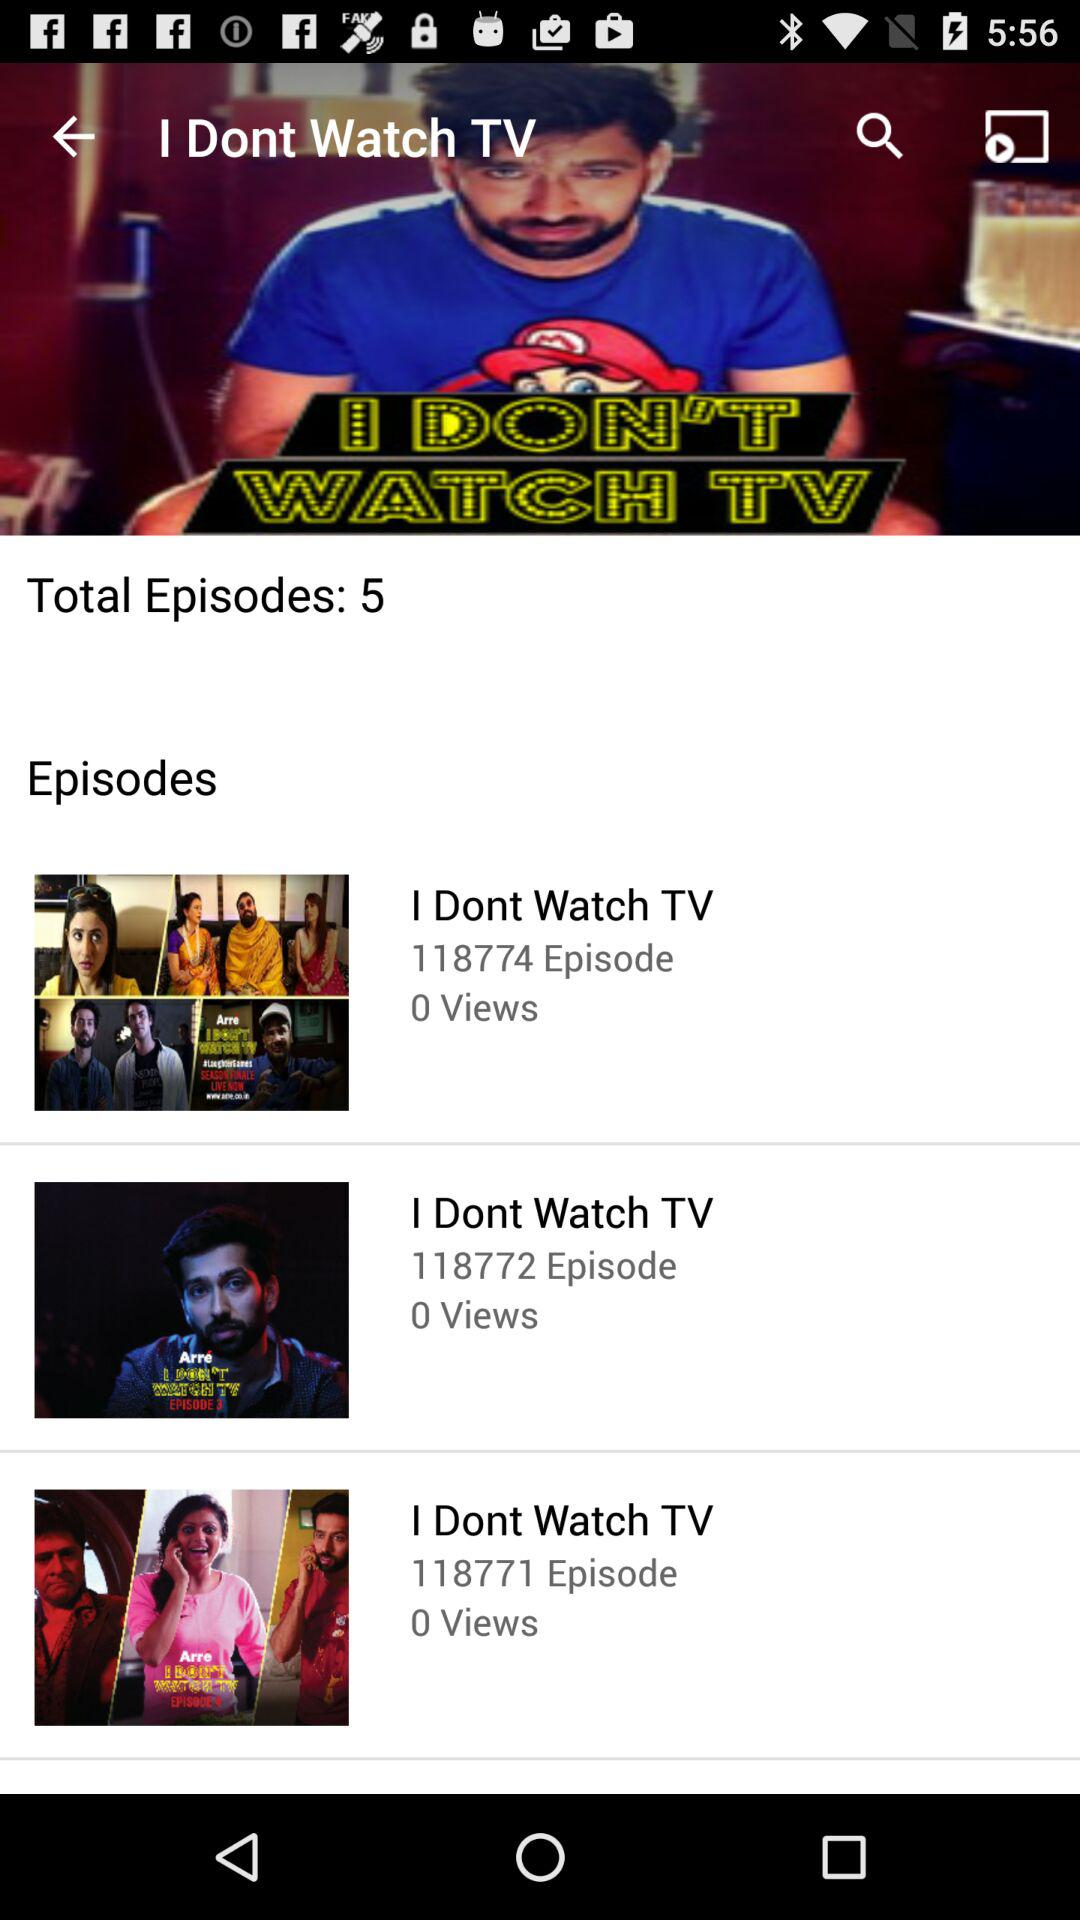How many episodes are in the series 'I Don't Watch TV'?
Answer the question using a single word or phrase. 5 